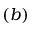<formula> <loc_0><loc_0><loc_500><loc_500>( b )</formula> 